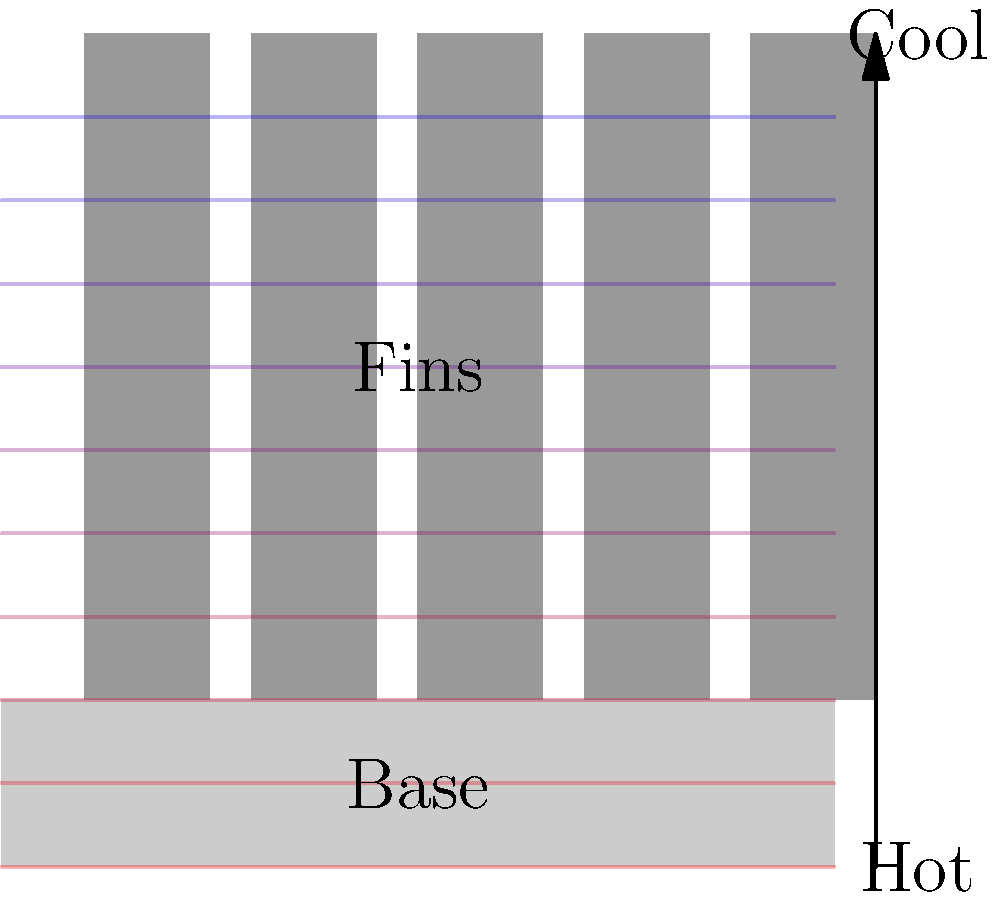In a heat sink with multiple fins, as shown in the diagram, how does the temperature typically vary from the base to the tip of the fins? Explain the reason for this temperature distribution pattern. To understand the temperature distribution in a heat sink with multiple fins, let's follow these steps:

1. Heat Source: The base of the heat sink is in direct contact with the heat source (e.g., a CPU or other electronic component). This makes the base the hottest part of the heat sink.

2. Heat Conduction: Heat is conducted from the base into the fins. The fins are made of a highly conductive material (usually aluminum or copper) to facilitate this process.

3. Temperature Gradient: As we move away from the base and up the fins, the temperature gradually decreases. This is due to two factors:
   a) Distance from the heat source
   b) Heat dissipation to the surrounding air

4. Fin Efficiency: The temperature is not uniform across the length of the fin. It's hottest at the base and coolest at the tip. This is because heat is continuously being dissipated to the air as it travels up the fin.

5. Heat Dissipation: The primary purpose of the fins is to increase the surface area for heat dissipation. As air flows over the fins (either by natural convection or forced convection), it carries away heat.

6. Tip Temperature: The tips of the fins are the coolest parts because they are farthest from the heat source and have been dissipating heat along their entire length.

The temperature distribution can be approximated by the equation:

$$ T(x) = T_b - \frac{T_b - T_\infty}{\cosh(mL)} \cosh(m(L-x)) $$

Where:
$T(x)$ is the temperature at distance $x$ from the base
$T_b$ is the base temperature
$T_\infty$ is the ambient air temperature
$L$ is the length of the fin
$m$ is a parameter depending on the fin's material and geometry

This equation shows that the temperature decreases non-linearly from the base to the tip, with the rate of decrease being steeper near the base and more gradual near the tip.
Answer: Temperature decreases non-linearly from base to tip due to continuous heat dissipation along the fin length. 